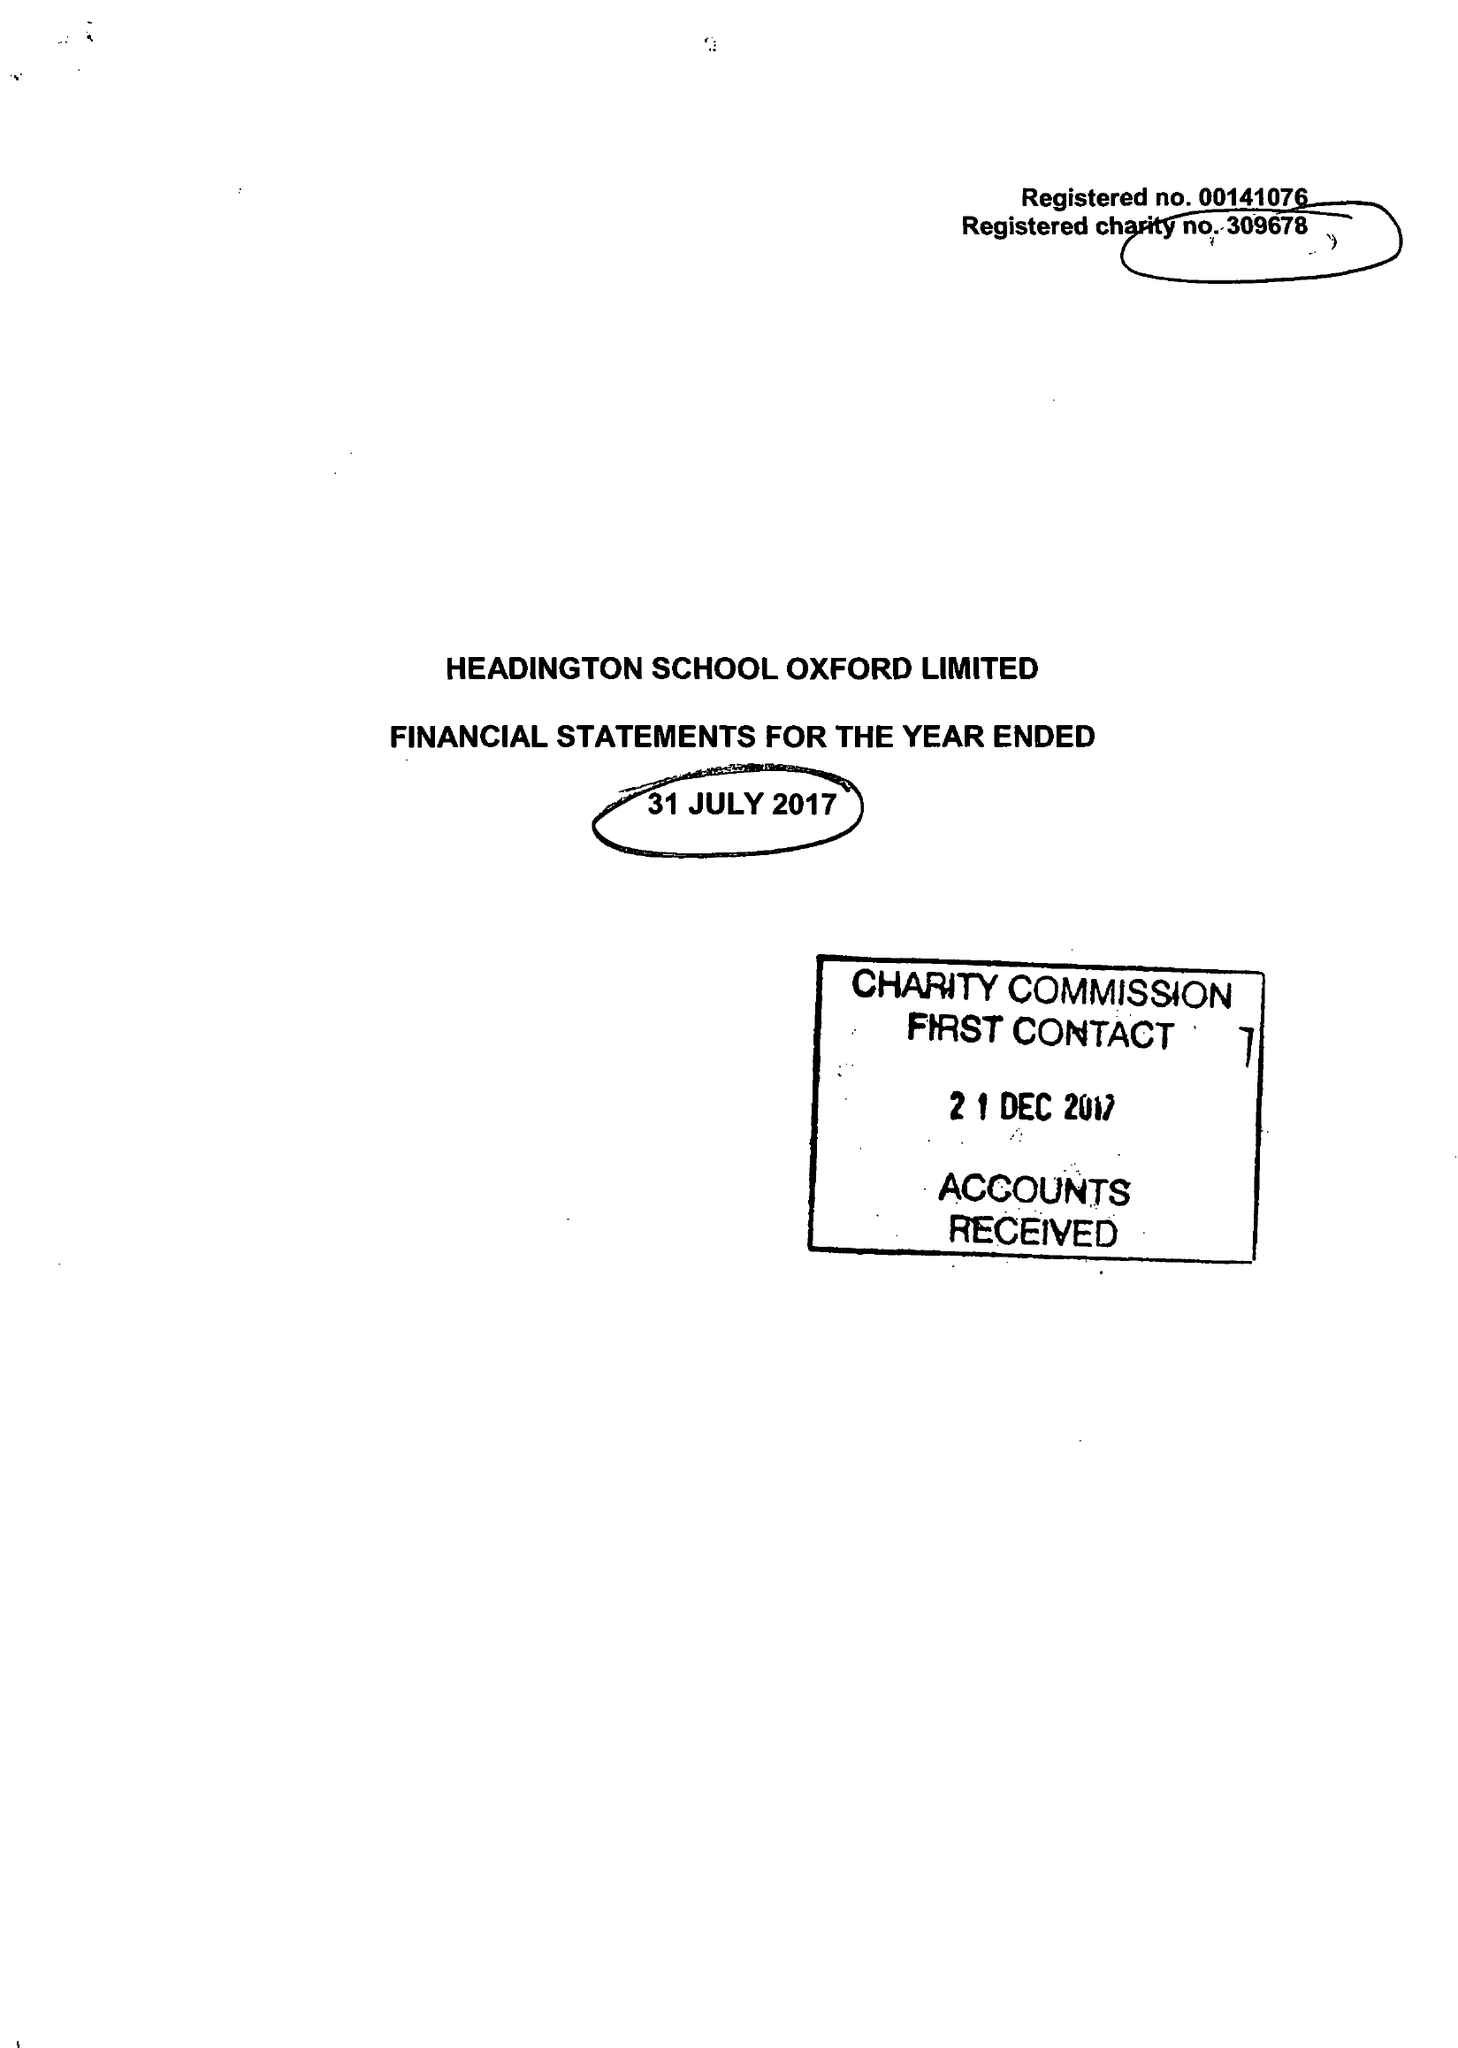What is the value for the charity_name?
Answer the question using a single word or phrase. Headington School Oxford Ltd. 